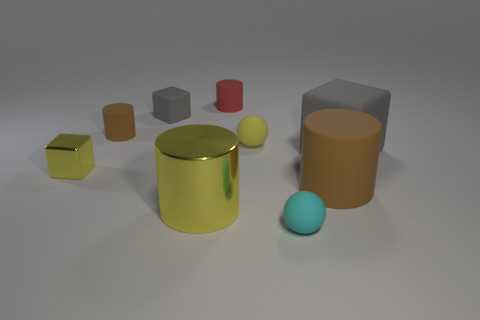What size is the metallic cylinder that is the same color as the small metallic thing?
Your answer should be compact. Large. Does the shiny cube have the same color as the big matte cylinder?
Offer a very short reply. No. What number of objects are big green matte cylinders or small cylinders that are behind the tiny cyan sphere?
Offer a terse response. 2. How many other things are there of the same shape as the small shiny thing?
Your answer should be very brief. 2. Is the number of yellow things that are on the right side of the big rubber cylinder less than the number of brown cylinders that are to the right of the tiny red cylinder?
Give a very brief answer. Yes. There is a cyan thing that is made of the same material as the big cube; what shape is it?
Provide a succinct answer. Sphere. Are there any other things of the same color as the tiny matte cube?
Make the answer very short. Yes. The small block in front of the gray cube behind the small brown thing is what color?
Offer a very short reply. Yellow. There is a tiny cube in front of the gray thing that is left of the small thing that is right of the tiny yellow ball; what is its material?
Give a very brief answer. Metal. How many balls have the same size as the shiny cube?
Your response must be concise. 2. 